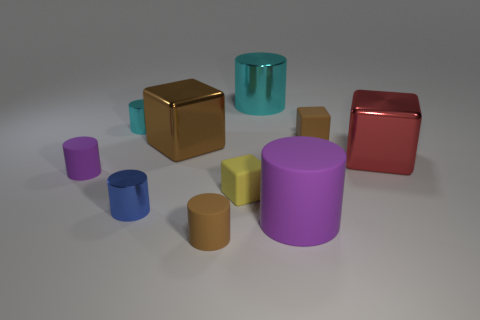There is a cylinder that is the same color as the large matte thing; what is its size?
Offer a very short reply. Small. How many things are on the right side of the big cylinder that is behind the purple rubber cylinder on the right side of the blue metallic object?
Provide a short and direct response. 3. Is the big matte thing the same color as the big metal cylinder?
Provide a short and direct response. No. Is there a big thing of the same color as the large matte cylinder?
Your response must be concise. No. What is the color of the other cube that is the same size as the red metal block?
Keep it short and to the point. Brown. Is there another shiny thing of the same shape as the big brown metallic object?
Keep it short and to the point. Yes. There is a rubber thing that is the same color as the large rubber cylinder; what shape is it?
Give a very brief answer. Cylinder. There is a large thing that is in front of the tiny metallic object in front of the big red block; is there a big cylinder to the left of it?
Ensure brevity in your answer.  Yes. What is the shape of the yellow thing that is the same size as the brown rubber block?
Your response must be concise. Cube. There is another small metallic thing that is the same shape as the tiny blue metal thing; what color is it?
Provide a short and direct response. Cyan. 